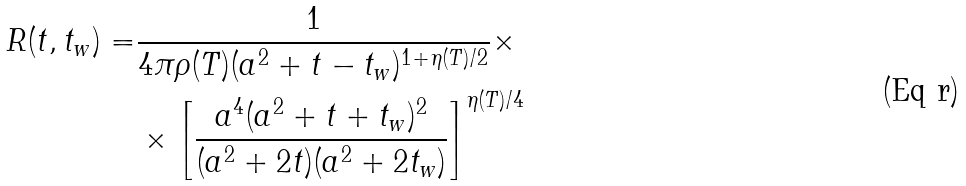Convert formula to latex. <formula><loc_0><loc_0><loc_500><loc_500>R ( t , t _ { w } ) = & \frac { 1 } { 4 \pi \rho ( T ) ( a ^ { 2 } + t - t _ { w } ) ^ { 1 + \eta ( T ) / 2 } } \times \\ & \times \left [ \frac { a ^ { 4 } ( a ^ { 2 } + t + t _ { w } ) ^ { 2 } } { ( a ^ { 2 } + 2 t ) ( a ^ { 2 } + 2 t _ { w } ) } \right ] ^ { \eta ( T ) / 4 }</formula> 